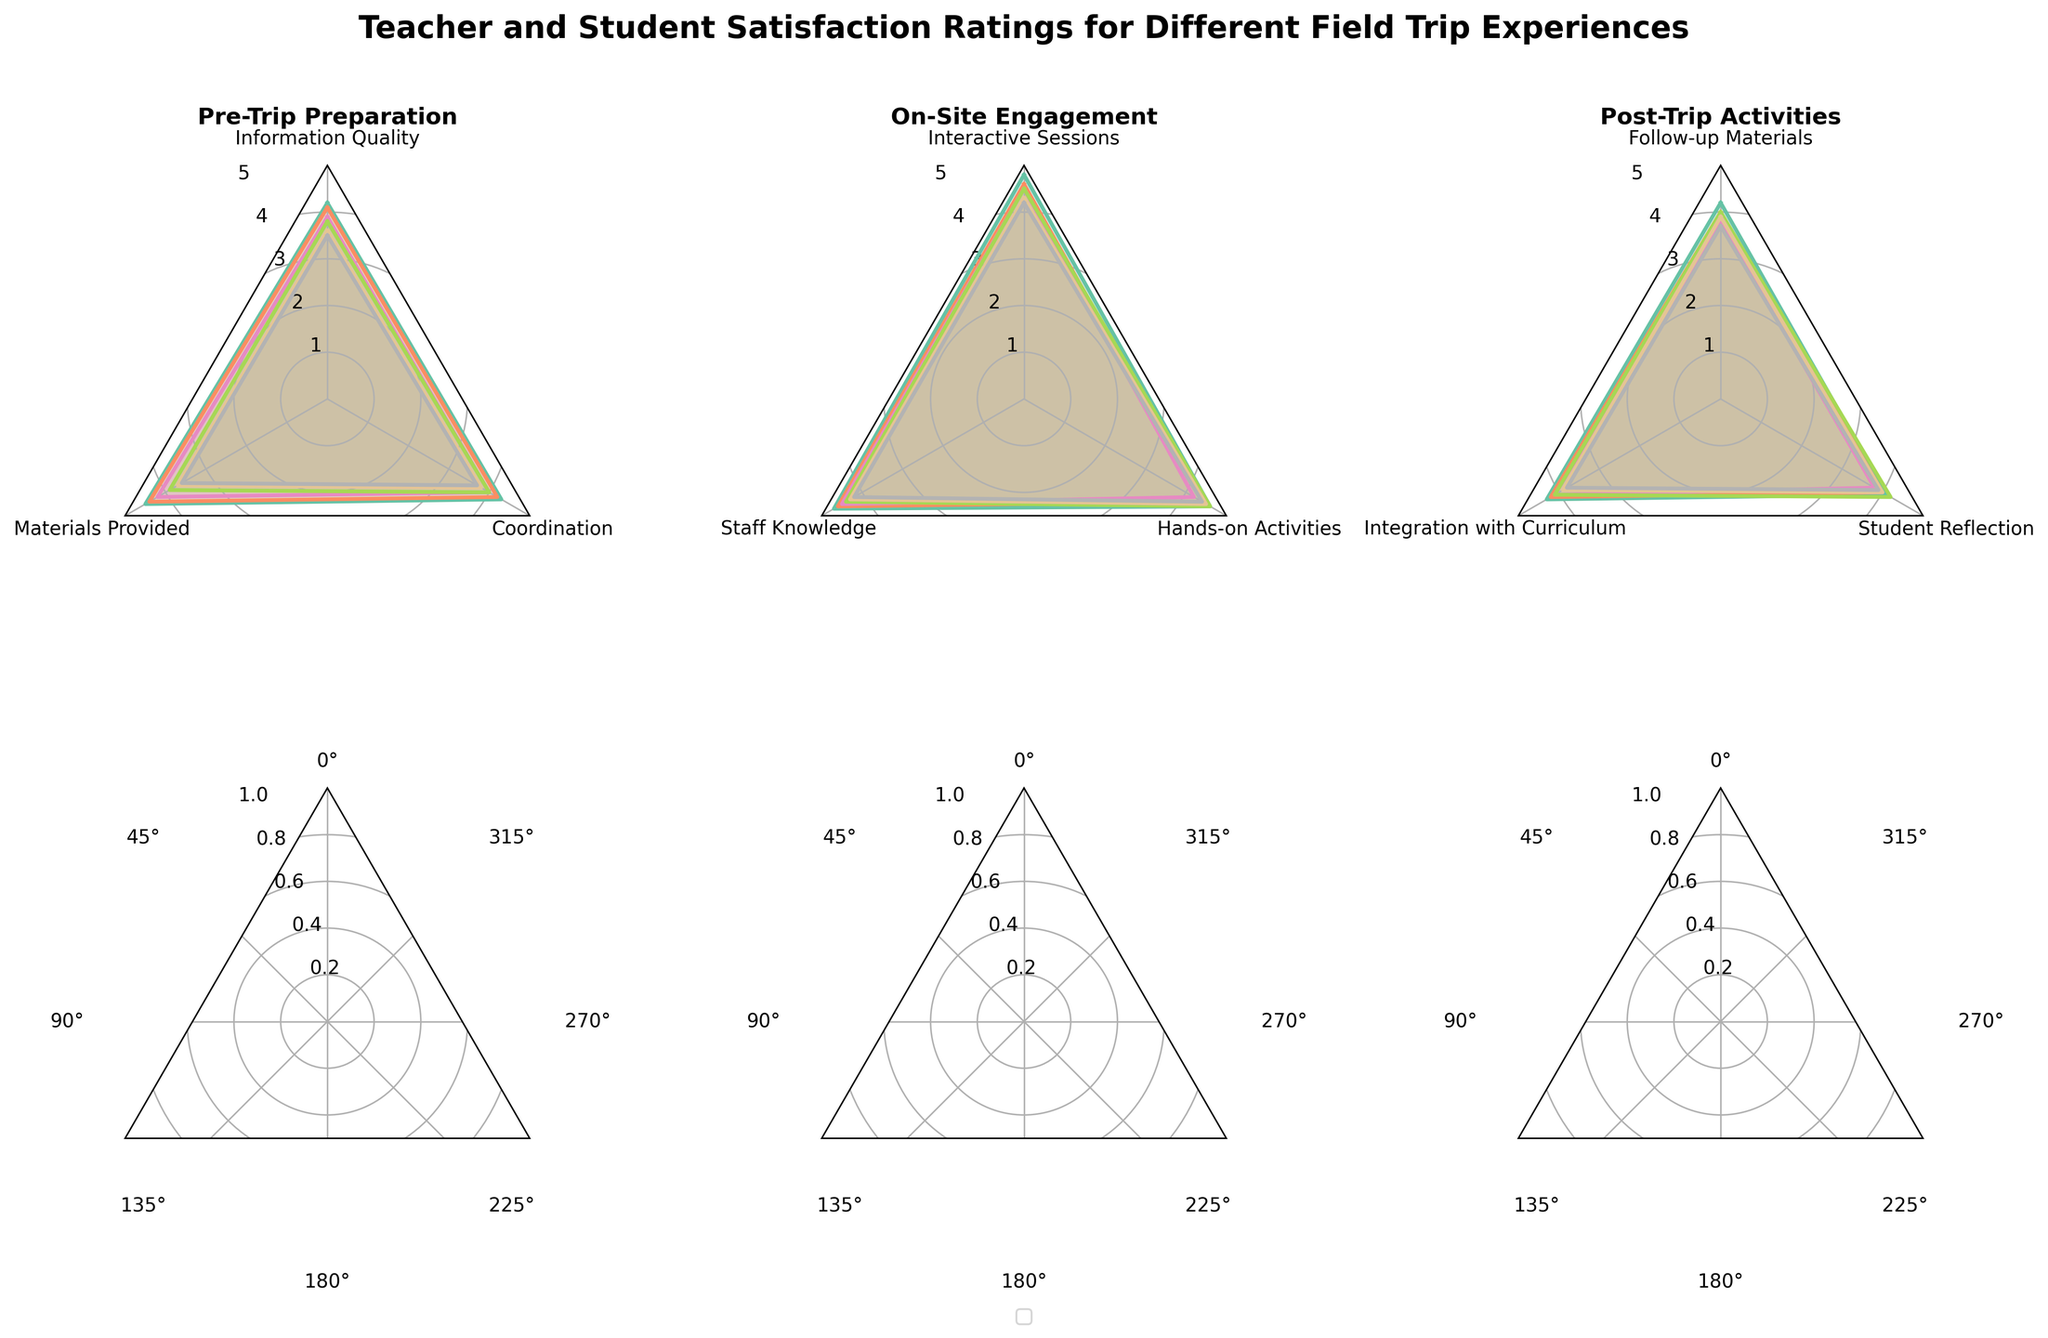What is the title of the radar chart? The title is located at the top center of the figure, it reads "Teacher and Student Satisfaction Ratings for Different Field Trip Experiences". This can be seen clearly from the visual text provided at the very top.
Answer: Teacher and Student Satisfaction Ratings for Different Field Trip Experiences In the Pre-Trip Preparation category, which criteria do teacher elementary ratings score the highest? To find this, focus on the "Pre-Trip Preparation" subplot and look for the highest value in the teacher elementary series, indicated by the corresponding line and shaded area. The highest rating among the criteria (Information Quality, Materials Provided, Coordination) for teacher elementary is 4.5 in Materials Provided.
Answer: Materials Provided Which student group shows the highest satisfaction in Hands-on Activities during On-Site Engagement? In the On-Site Engagement subplot, look for the label "Hands-on Activities" and compare the values for all student groups (Elementary, Middle, High). The highest rating is 4.6 for student elementary.
Answer: Student Elementary Are there any criteria in Post-Trip Activities where the student high and teacher high ratings are equal? In the Post-Trip Activities subplot, observe the lines corresponding to student high and teacher high for each criterion (Follow-up Materials, Integration with Curriculum, Student Reflection). For Integration with Curriculum, both groups have a rating of 3.8.
Answer: Integration with Curriculum Which criteria in On-Site Engagement shows the smallest difference between student middle and student high ratings? In the On-Site Engagement subplot, visually compare the differences between the student middle and student high ratings for each criterion (Interactive Sessions, Staff Knowledge, Hands-on Activities). The smallest difference is in Hands-on Activities (difference of 4.5 - 4.4 = 0.1).
Answer: Hands-on Activities What is the average rating for teacher middle across all criteria in the Pre-Trip Preparation category? To find the average rating, sum the teacher middle ratings for all Pre-Trip Preparation criteria (Information Quality, Materials Provided, Coordination) and divide by the number of criteria. Calculation: (4.1 + 4.4 + 4.2) / 3 = 12.7 / 3 = 4.23
Answer: 4.23 Which group shows the largest range of satisfaction ratings in the Post-Trip Activities category? The range is calculated by subtracting the smallest rating from the largest rating within each group. Compare the ranges for each group (teacher elementary, teacher middle, teacher high, student elementary, student middle, student high). The student high range is (3.9 - 3.7) = 0.2, for example. The teacher elementary has the largest range (4.3 - 4.1) = 0.2.
Answer: Teacher Elementary Between teacher high and student high, who has the higher average rating in the On-Site Engagement category? Calculate the average rating for both groups by summing their ratings for the criteria in On-Site Engagement (teacher high: 4.5 + 4.5 + 4.2, student high: 4.2 + 4.2 + 4.4). Then, divide by the number of criteria. Teacher high average: (4.5 + 4.5 + 4.2) / 3 = 13.2 / 3 = 4.40. Student high average: (4.2 + 4.2 + 4.4) / 3 = 12.8 / 3 = 4.27. Therefore, teacher high has a higher average rating.
Answer: Teacher High Which criterion in the Pre-Trip Preparation category shows the highest discrepancy between teacher elementary and student elementary ratings? Focus on the Pre-Trip Preparation subplot. Calculate the differences for each criterion (Information Quality, Materials Provided, Coordination) by subtracting student elementary ratings from teacher elementary ratings. The highest discrepancy is in Materials Provided, where the difference is 4.5 - 3.9 = 0.6.
Answer: Materials Provided 